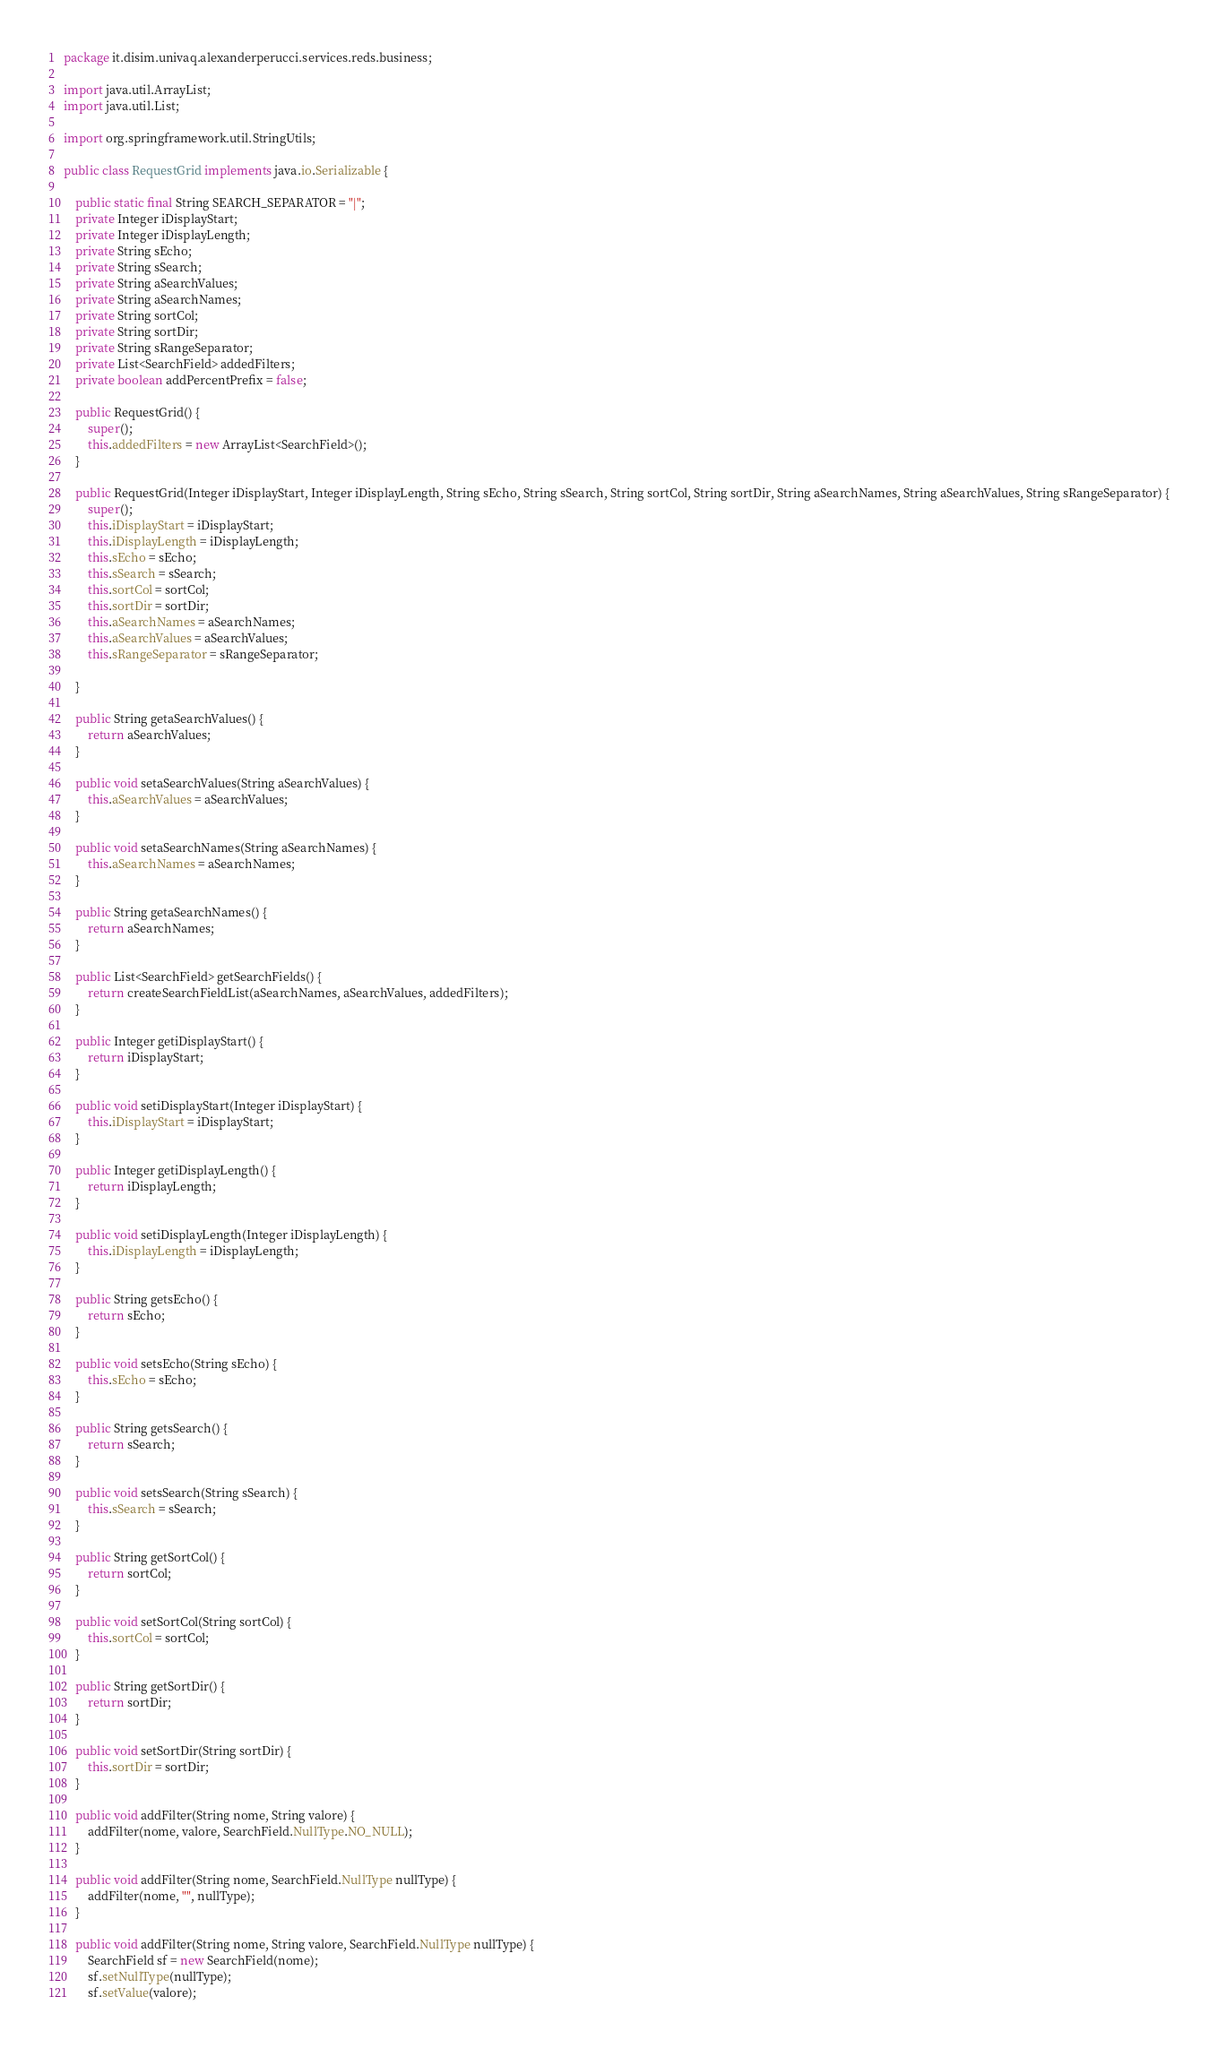<code> <loc_0><loc_0><loc_500><loc_500><_Java_>package it.disim.univaq.alexanderperucci.services.reds.business;

import java.util.ArrayList;
import java.util.List;

import org.springframework.util.StringUtils;

public class RequestGrid implements java.io.Serializable {

	public static final String SEARCH_SEPARATOR = "|";
	private Integer iDisplayStart;
	private Integer iDisplayLength;
	private String sEcho;
	private String sSearch;
	private String aSearchValues;
	private String aSearchNames;
	private String sortCol;
	private String sortDir;
	private String sRangeSeparator;
	private List<SearchField> addedFilters;
	private boolean addPercentPrefix = false;

	public RequestGrid() {
		super();
		this.addedFilters = new ArrayList<SearchField>();
	}

	public RequestGrid(Integer iDisplayStart, Integer iDisplayLength, String sEcho, String sSearch, String sortCol, String sortDir, String aSearchNames, String aSearchValues, String sRangeSeparator) {
		super();
		this.iDisplayStart = iDisplayStart;
		this.iDisplayLength = iDisplayLength;
		this.sEcho = sEcho;
		this.sSearch = sSearch;
		this.sortCol = sortCol;
		this.sortDir = sortDir;
		this.aSearchNames = aSearchNames;
		this.aSearchValues = aSearchValues;
		this.sRangeSeparator = sRangeSeparator;

	}

	public String getaSearchValues() {
		return aSearchValues;
	}

	public void setaSearchValues(String aSearchValues) {
		this.aSearchValues = aSearchValues;
	}

	public void setaSearchNames(String aSearchNames) {
		this.aSearchNames = aSearchNames;
	}

	public String getaSearchNames() {
		return aSearchNames;
	}

	public List<SearchField> getSearchFields() {
		return createSearchFieldList(aSearchNames, aSearchValues, addedFilters);
	}

	public Integer getiDisplayStart() {
		return iDisplayStart;
	}

	public void setiDisplayStart(Integer iDisplayStart) {
		this.iDisplayStart = iDisplayStart;
	}

	public Integer getiDisplayLength() {
		return iDisplayLength;
	}

	public void setiDisplayLength(Integer iDisplayLength) {
		this.iDisplayLength = iDisplayLength;
	}

	public String getsEcho() {
		return sEcho;
	}

	public void setsEcho(String sEcho) {
		this.sEcho = sEcho;
	}

	public String getsSearch() {
		return sSearch;
	}

	public void setsSearch(String sSearch) {
		this.sSearch = sSearch;
	}

	public String getSortCol() {
		return sortCol;
	}

	public void setSortCol(String sortCol) {
		this.sortCol = sortCol;
	}

	public String getSortDir() {
		return sortDir;
	}

	public void setSortDir(String sortDir) {
		this.sortDir = sortDir;
	}

	public void addFilter(String nome, String valore) {
		addFilter(nome, valore, SearchField.NullType.NO_NULL);
	}

	public void addFilter(String nome, SearchField.NullType nullType) {
		addFilter(nome, "", nullType);
	}

	public void addFilter(String nome, String valore, SearchField.NullType nullType) {
		SearchField sf = new SearchField(nome);
		sf.setNullType(nullType);
		sf.setValue(valore);</code> 